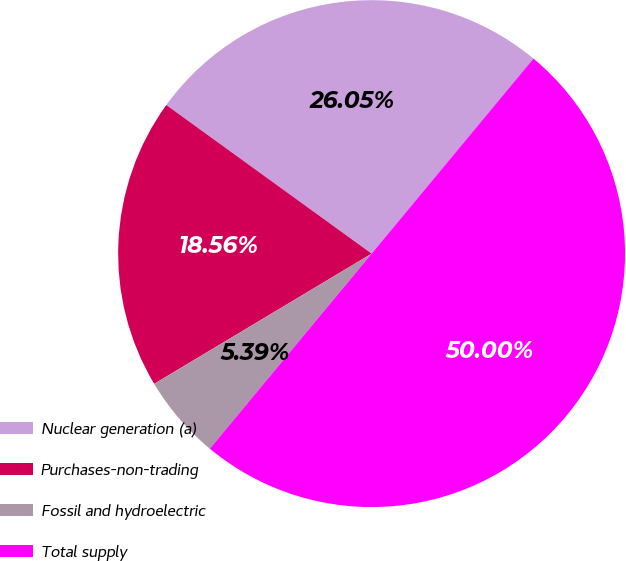Convert chart to OTSL. <chart><loc_0><loc_0><loc_500><loc_500><pie_chart><fcel>Nuclear generation (a)<fcel>Purchases-non-trading<fcel>Fossil and hydroelectric<fcel>Total supply<nl><fcel>26.05%<fcel>18.56%<fcel>5.39%<fcel>50.0%<nl></chart> 